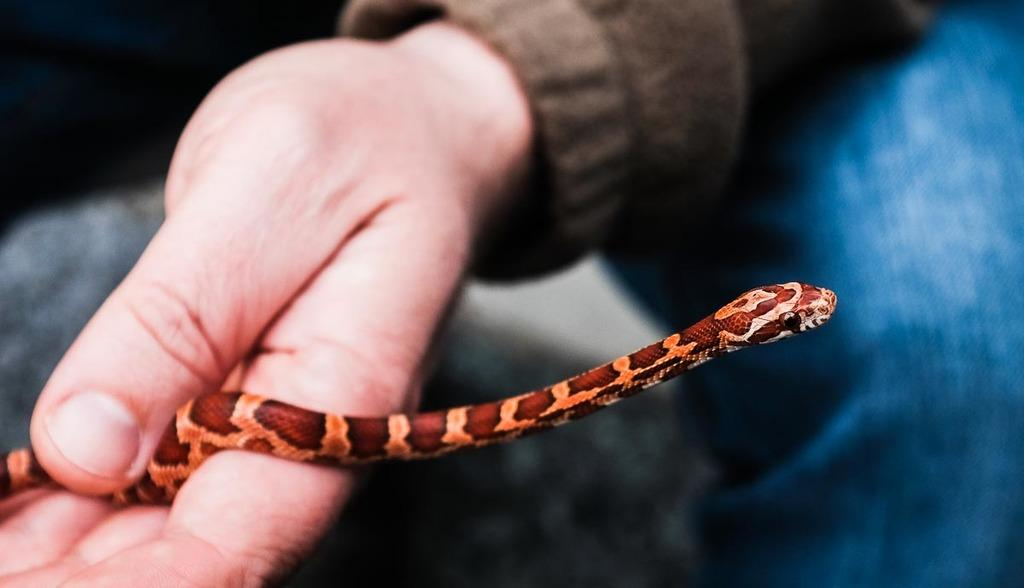Who or what is the main subject in the image? There is a person in the image. Can you describe the person's attire? The person is wearing a brown and blue colored dress. What is the person holding in the image? The person is holding a snake. What is the color of the snake? The snake is brown in color. Where is the tramp performing in the image? There is no tramp present in the image; it features a person holding a snake. What type of show is the person putting on with the snake? There is no show or performance depicted in the image; the person is simply holding a snake. 